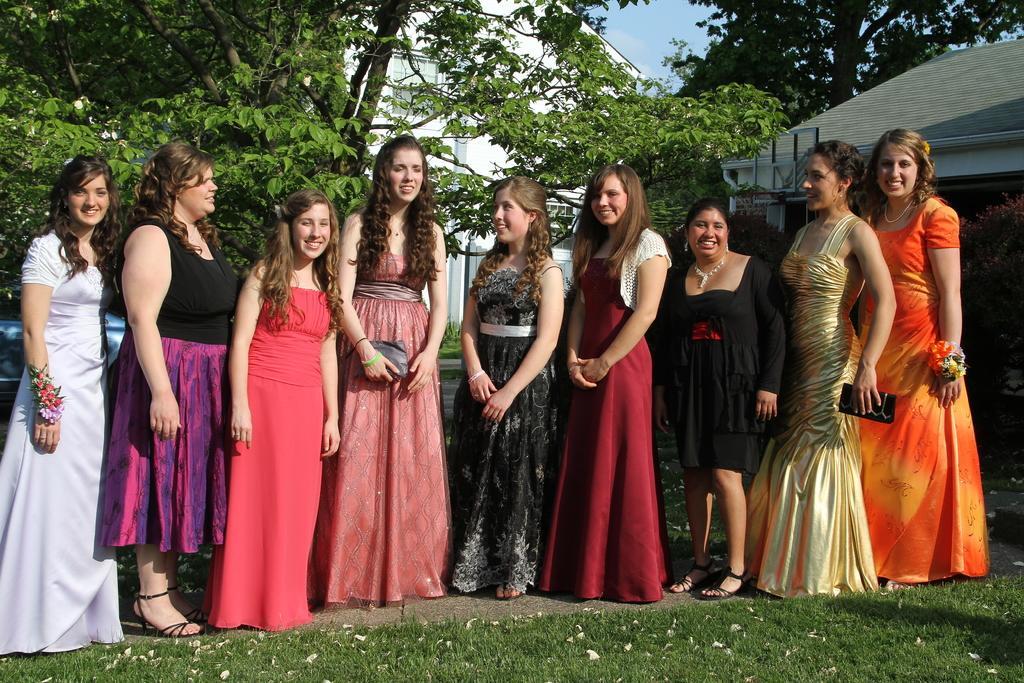Describe this image in one or two sentences. In this image in the front there's grass on the ground. In the center there are women standing and smiling. In the background there are houses and trees and the sky is cloudy. 